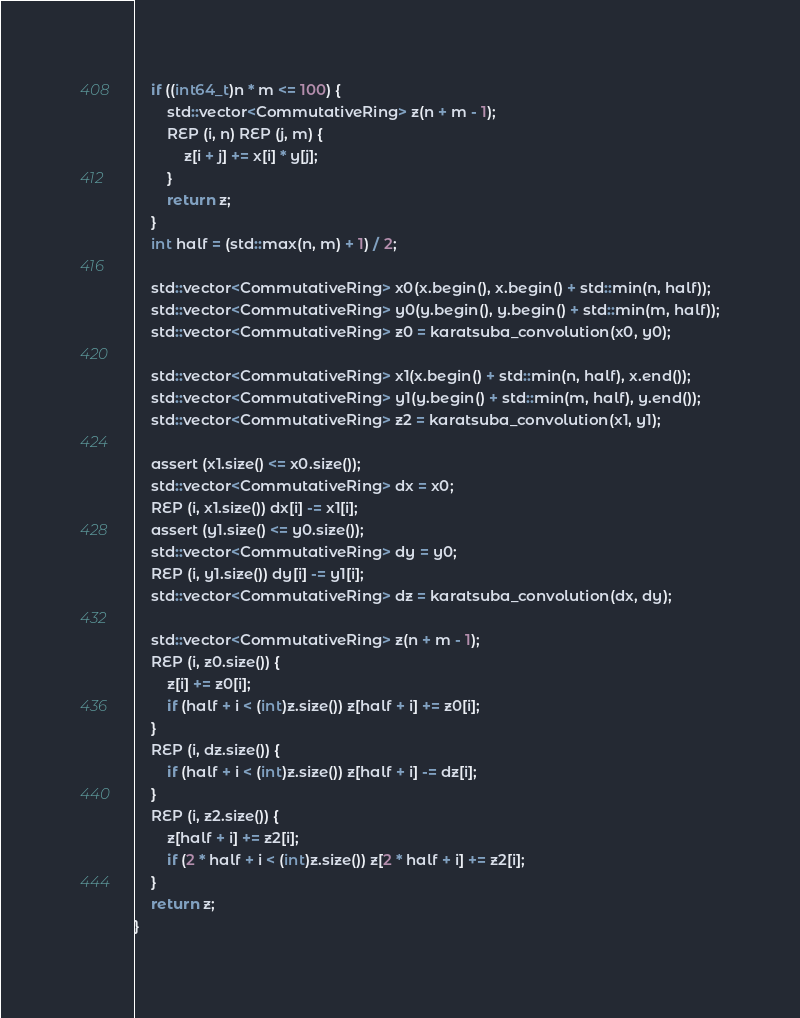Convert code to text. <code><loc_0><loc_0><loc_500><loc_500><_C++_>    if ((int64_t)n * m <= 100) {
        std::vector<CommutativeRing> z(n + m - 1);
        REP (i, n) REP (j, m) {
            z[i + j] += x[i] * y[j];
        }
        return z;
    }
    int half = (std::max(n, m) + 1) / 2;

    std::vector<CommutativeRing> x0(x.begin(), x.begin() + std::min(n, half));
    std::vector<CommutativeRing> y0(y.begin(), y.begin() + std::min(m, half));
    std::vector<CommutativeRing> z0 = karatsuba_convolution(x0, y0);

    std::vector<CommutativeRing> x1(x.begin() + std::min(n, half), x.end());
    std::vector<CommutativeRing> y1(y.begin() + std::min(m, half), y.end());
    std::vector<CommutativeRing> z2 = karatsuba_convolution(x1, y1);

    assert (x1.size() <= x0.size());
    std::vector<CommutativeRing> dx = x0;
    REP (i, x1.size()) dx[i] -= x1[i];
    assert (y1.size() <= y0.size());
    std::vector<CommutativeRing> dy = y0;
    REP (i, y1.size()) dy[i] -= y1[i];
    std::vector<CommutativeRing> dz = karatsuba_convolution(dx, dy);

    std::vector<CommutativeRing> z(n + m - 1);
    REP (i, z0.size()) {
        z[i] += z0[i];
        if (half + i < (int)z.size()) z[half + i] += z0[i];
    }
    REP (i, dz.size()) {
        if (half + i < (int)z.size()) z[half + i] -= dz[i];
    }
    REP (i, z2.size()) {
        z[half + i] += z2[i];
        if (2 * half + i < (int)z.size()) z[2 * half + i] += z2[i];
    }
    return z;
}
</code> 